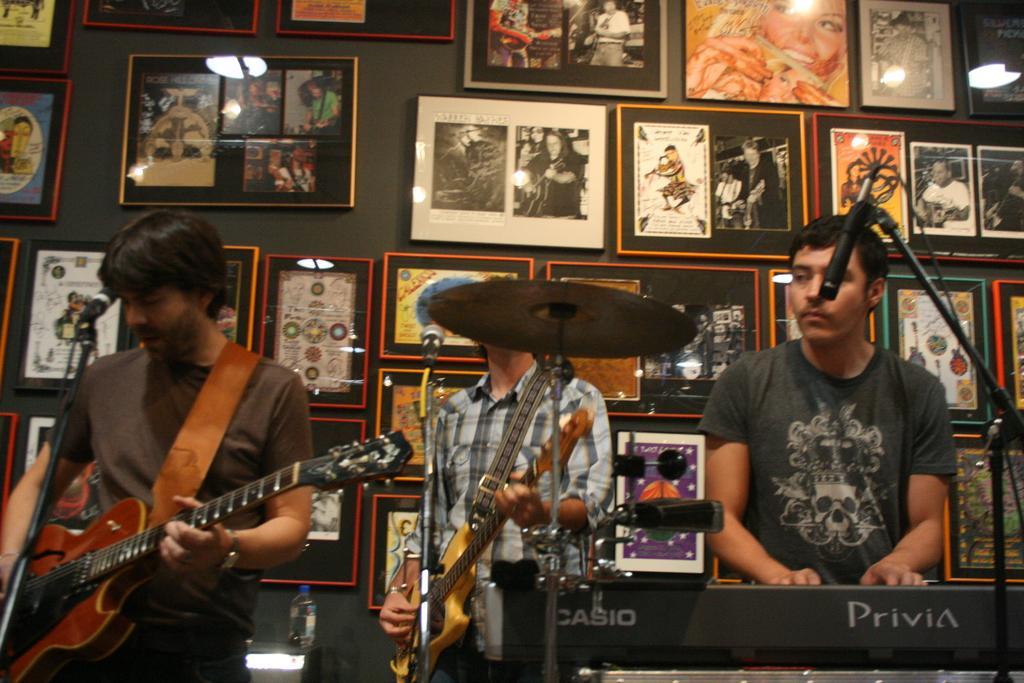In one or two sentences, can you explain what this image depicts? In the middle there is a man he wear check shirt he hold a guitar. On the right there is a man he wear black t shirt , he is playing piano. On the left there is a man he wear brown t shirt and trouser ,he holds guitar. I think this is a stage performance. In the background there are many photo frames and wall. 